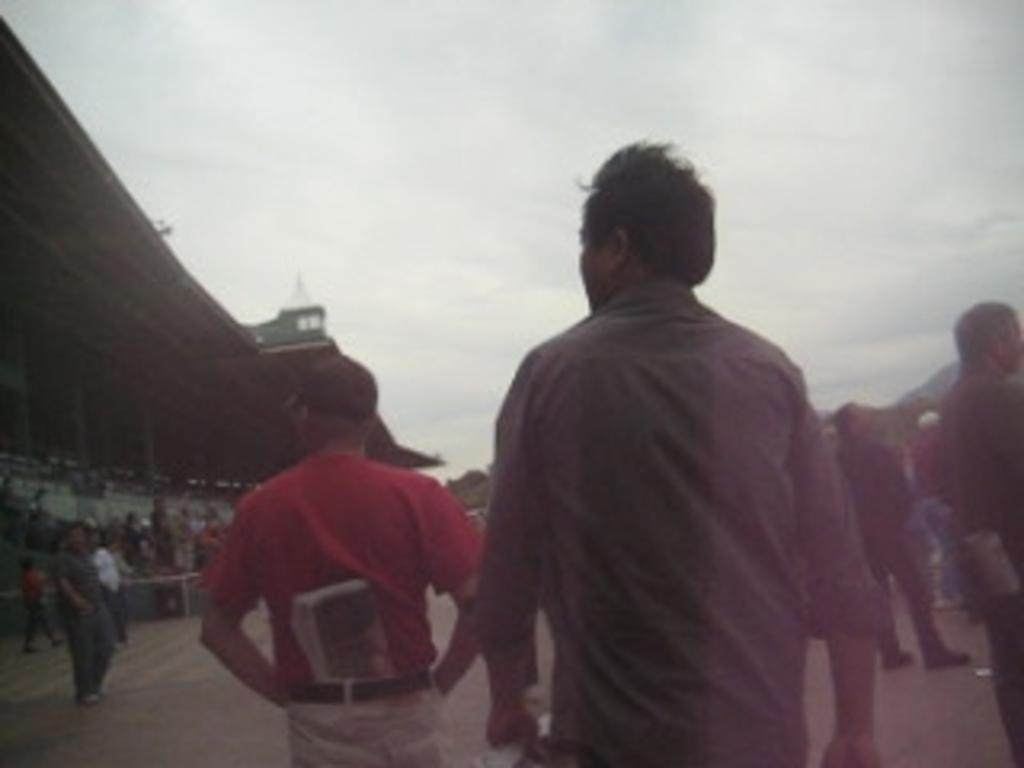What is happening in the image involving the people? There are many people walking in the image. Can you describe the setting of the image? The image appears to be of a stadium. What structure is located to the left in the image? There is a shed to the left in the image. What can be seen at the bottom of the image? The ground is visible at the bottom of the image. What is visible in the sky at the top of the image? There are clouds in the sky at the top of the image. What type of quince is being served in the stadium? There is no quince present in the image; it is a stadium with people walking and a shed to the left. How many people are getting a haircut in the image? There is no indication of anyone getting a haircut in the image; it shows people walking in a stadium setting. 